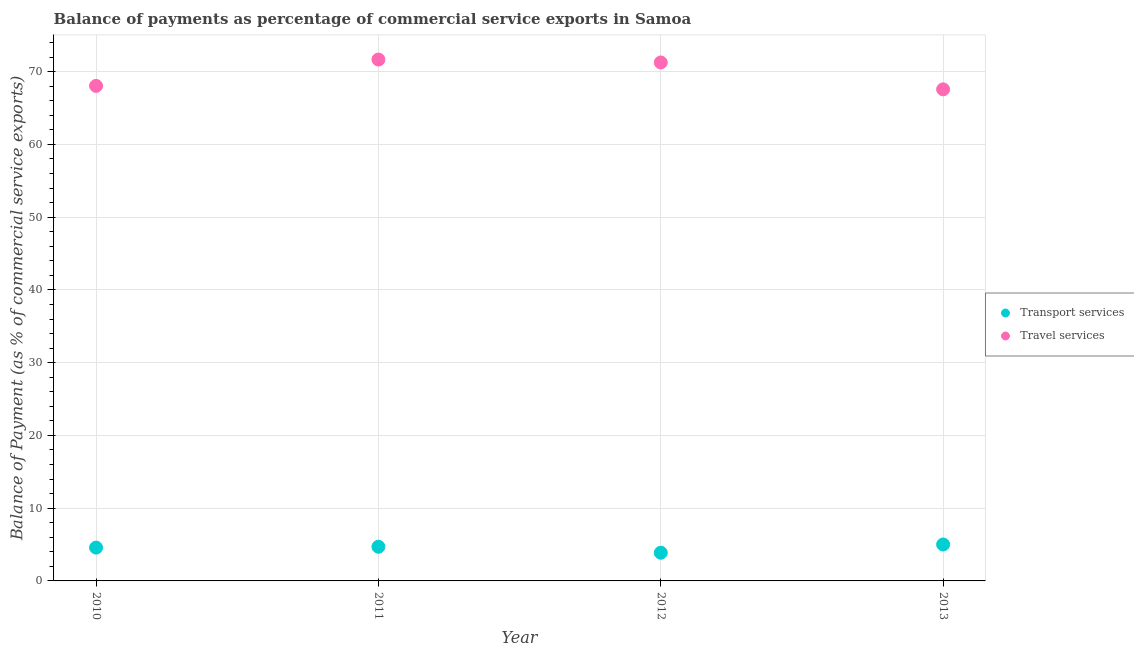Is the number of dotlines equal to the number of legend labels?
Provide a succinct answer. Yes. What is the balance of payments of travel services in 2012?
Give a very brief answer. 71.27. Across all years, what is the maximum balance of payments of transport services?
Keep it short and to the point. 5.01. Across all years, what is the minimum balance of payments of transport services?
Offer a terse response. 3.88. In which year was the balance of payments of travel services maximum?
Your answer should be compact. 2011. What is the total balance of payments of transport services in the graph?
Offer a very short reply. 18.16. What is the difference between the balance of payments of travel services in 2011 and that in 2012?
Provide a short and direct response. 0.4. What is the difference between the balance of payments of transport services in 2011 and the balance of payments of travel services in 2012?
Your response must be concise. -66.57. What is the average balance of payments of transport services per year?
Offer a very short reply. 4.54. In the year 2011, what is the difference between the balance of payments of travel services and balance of payments of transport services?
Your response must be concise. 66.97. In how many years, is the balance of payments of travel services greater than 6 %?
Provide a succinct answer. 4. What is the ratio of the balance of payments of travel services in 2011 to that in 2013?
Offer a terse response. 1.06. What is the difference between the highest and the second highest balance of payments of travel services?
Offer a terse response. 0.4. What is the difference between the highest and the lowest balance of payments of travel services?
Your answer should be compact. 4.1. In how many years, is the balance of payments of transport services greater than the average balance of payments of transport services taken over all years?
Offer a terse response. 3. Does the balance of payments of travel services monotonically increase over the years?
Your response must be concise. No. Is the balance of payments of travel services strictly less than the balance of payments of transport services over the years?
Keep it short and to the point. No. How many dotlines are there?
Offer a very short reply. 2. Are the values on the major ticks of Y-axis written in scientific E-notation?
Ensure brevity in your answer.  No. How many legend labels are there?
Provide a short and direct response. 2. What is the title of the graph?
Offer a very short reply. Balance of payments as percentage of commercial service exports in Samoa. What is the label or title of the X-axis?
Give a very brief answer. Year. What is the label or title of the Y-axis?
Your response must be concise. Balance of Payment (as % of commercial service exports). What is the Balance of Payment (as % of commercial service exports) in Transport services in 2010?
Give a very brief answer. 4.58. What is the Balance of Payment (as % of commercial service exports) of Travel services in 2010?
Your answer should be compact. 68.05. What is the Balance of Payment (as % of commercial service exports) of Transport services in 2011?
Make the answer very short. 4.7. What is the Balance of Payment (as % of commercial service exports) of Travel services in 2011?
Your response must be concise. 71.67. What is the Balance of Payment (as % of commercial service exports) in Transport services in 2012?
Provide a succinct answer. 3.88. What is the Balance of Payment (as % of commercial service exports) of Travel services in 2012?
Provide a succinct answer. 71.27. What is the Balance of Payment (as % of commercial service exports) in Transport services in 2013?
Provide a short and direct response. 5.01. What is the Balance of Payment (as % of commercial service exports) in Travel services in 2013?
Give a very brief answer. 67.57. Across all years, what is the maximum Balance of Payment (as % of commercial service exports) of Transport services?
Give a very brief answer. 5.01. Across all years, what is the maximum Balance of Payment (as % of commercial service exports) in Travel services?
Your answer should be compact. 71.67. Across all years, what is the minimum Balance of Payment (as % of commercial service exports) in Transport services?
Provide a short and direct response. 3.88. Across all years, what is the minimum Balance of Payment (as % of commercial service exports) in Travel services?
Give a very brief answer. 67.57. What is the total Balance of Payment (as % of commercial service exports) in Transport services in the graph?
Offer a very short reply. 18.16. What is the total Balance of Payment (as % of commercial service exports) of Travel services in the graph?
Offer a very short reply. 278.56. What is the difference between the Balance of Payment (as % of commercial service exports) in Transport services in 2010 and that in 2011?
Ensure brevity in your answer.  -0.12. What is the difference between the Balance of Payment (as % of commercial service exports) in Travel services in 2010 and that in 2011?
Give a very brief answer. -3.62. What is the difference between the Balance of Payment (as % of commercial service exports) of Transport services in 2010 and that in 2012?
Provide a succinct answer. 0.7. What is the difference between the Balance of Payment (as % of commercial service exports) of Travel services in 2010 and that in 2012?
Your answer should be very brief. -3.22. What is the difference between the Balance of Payment (as % of commercial service exports) in Transport services in 2010 and that in 2013?
Offer a terse response. -0.43. What is the difference between the Balance of Payment (as % of commercial service exports) in Travel services in 2010 and that in 2013?
Your response must be concise. 0.47. What is the difference between the Balance of Payment (as % of commercial service exports) in Transport services in 2011 and that in 2012?
Give a very brief answer. 0.82. What is the difference between the Balance of Payment (as % of commercial service exports) of Travel services in 2011 and that in 2012?
Provide a short and direct response. 0.4. What is the difference between the Balance of Payment (as % of commercial service exports) of Transport services in 2011 and that in 2013?
Offer a very short reply. -0.31. What is the difference between the Balance of Payment (as % of commercial service exports) in Travel services in 2011 and that in 2013?
Your answer should be very brief. 4.1. What is the difference between the Balance of Payment (as % of commercial service exports) in Transport services in 2012 and that in 2013?
Offer a terse response. -1.13. What is the difference between the Balance of Payment (as % of commercial service exports) in Travel services in 2012 and that in 2013?
Your answer should be very brief. 3.7. What is the difference between the Balance of Payment (as % of commercial service exports) of Transport services in 2010 and the Balance of Payment (as % of commercial service exports) of Travel services in 2011?
Provide a succinct answer. -67.09. What is the difference between the Balance of Payment (as % of commercial service exports) of Transport services in 2010 and the Balance of Payment (as % of commercial service exports) of Travel services in 2012?
Provide a short and direct response. -66.69. What is the difference between the Balance of Payment (as % of commercial service exports) of Transport services in 2010 and the Balance of Payment (as % of commercial service exports) of Travel services in 2013?
Ensure brevity in your answer.  -62.99. What is the difference between the Balance of Payment (as % of commercial service exports) of Transport services in 2011 and the Balance of Payment (as % of commercial service exports) of Travel services in 2012?
Your answer should be very brief. -66.57. What is the difference between the Balance of Payment (as % of commercial service exports) in Transport services in 2011 and the Balance of Payment (as % of commercial service exports) in Travel services in 2013?
Make the answer very short. -62.88. What is the difference between the Balance of Payment (as % of commercial service exports) of Transport services in 2012 and the Balance of Payment (as % of commercial service exports) of Travel services in 2013?
Give a very brief answer. -63.7. What is the average Balance of Payment (as % of commercial service exports) of Transport services per year?
Keep it short and to the point. 4.54. What is the average Balance of Payment (as % of commercial service exports) in Travel services per year?
Give a very brief answer. 69.64. In the year 2010, what is the difference between the Balance of Payment (as % of commercial service exports) in Transport services and Balance of Payment (as % of commercial service exports) in Travel services?
Provide a succinct answer. -63.47. In the year 2011, what is the difference between the Balance of Payment (as % of commercial service exports) in Transport services and Balance of Payment (as % of commercial service exports) in Travel services?
Your response must be concise. -66.97. In the year 2012, what is the difference between the Balance of Payment (as % of commercial service exports) of Transport services and Balance of Payment (as % of commercial service exports) of Travel services?
Offer a very short reply. -67.39. In the year 2013, what is the difference between the Balance of Payment (as % of commercial service exports) in Transport services and Balance of Payment (as % of commercial service exports) in Travel services?
Give a very brief answer. -62.56. What is the ratio of the Balance of Payment (as % of commercial service exports) in Transport services in 2010 to that in 2011?
Ensure brevity in your answer.  0.97. What is the ratio of the Balance of Payment (as % of commercial service exports) in Travel services in 2010 to that in 2011?
Your answer should be very brief. 0.95. What is the ratio of the Balance of Payment (as % of commercial service exports) of Transport services in 2010 to that in 2012?
Make the answer very short. 1.18. What is the ratio of the Balance of Payment (as % of commercial service exports) in Travel services in 2010 to that in 2012?
Your answer should be compact. 0.95. What is the ratio of the Balance of Payment (as % of commercial service exports) of Transport services in 2010 to that in 2013?
Provide a succinct answer. 0.91. What is the ratio of the Balance of Payment (as % of commercial service exports) of Transport services in 2011 to that in 2012?
Give a very brief answer. 1.21. What is the ratio of the Balance of Payment (as % of commercial service exports) of Travel services in 2011 to that in 2012?
Provide a succinct answer. 1.01. What is the ratio of the Balance of Payment (as % of commercial service exports) of Transport services in 2011 to that in 2013?
Provide a succinct answer. 0.94. What is the ratio of the Balance of Payment (as % of commercial service exports) of Travel services in 2011 to that in 2013?
Keep it short and to the point. 1.06. What is the ratio of the Balance of Payment (as % of commercial service exports) of Transport services in 2012 to that in 2013?
Ensure brevity in your answer.  0.77. What is the ratio of the Balance of Payment (as % of commercial service exports) of Travel services in 2012 to that in 2013?
Ensure brevity in your answer.  1.05. What is the difference between the highest and the second highest Balance of Payment (as % of commercial service exports) of Transport services?
Offer a terse response. 0.31. What is the difference between the highest and the second highest Balance of Payment (as % of commercial service exports) of Travel services?
Make the answer very short. 0.4. What is the difference between the highest and the lowest Balance of Payment (as % of commercial service exports) of Transport services?
Offer a terse response. 1.13. What is the difference between the highest and the lowest Balance of Payment (as % of commercial service exports) in Travel services?
Provide a succinct answer. 4.1. 